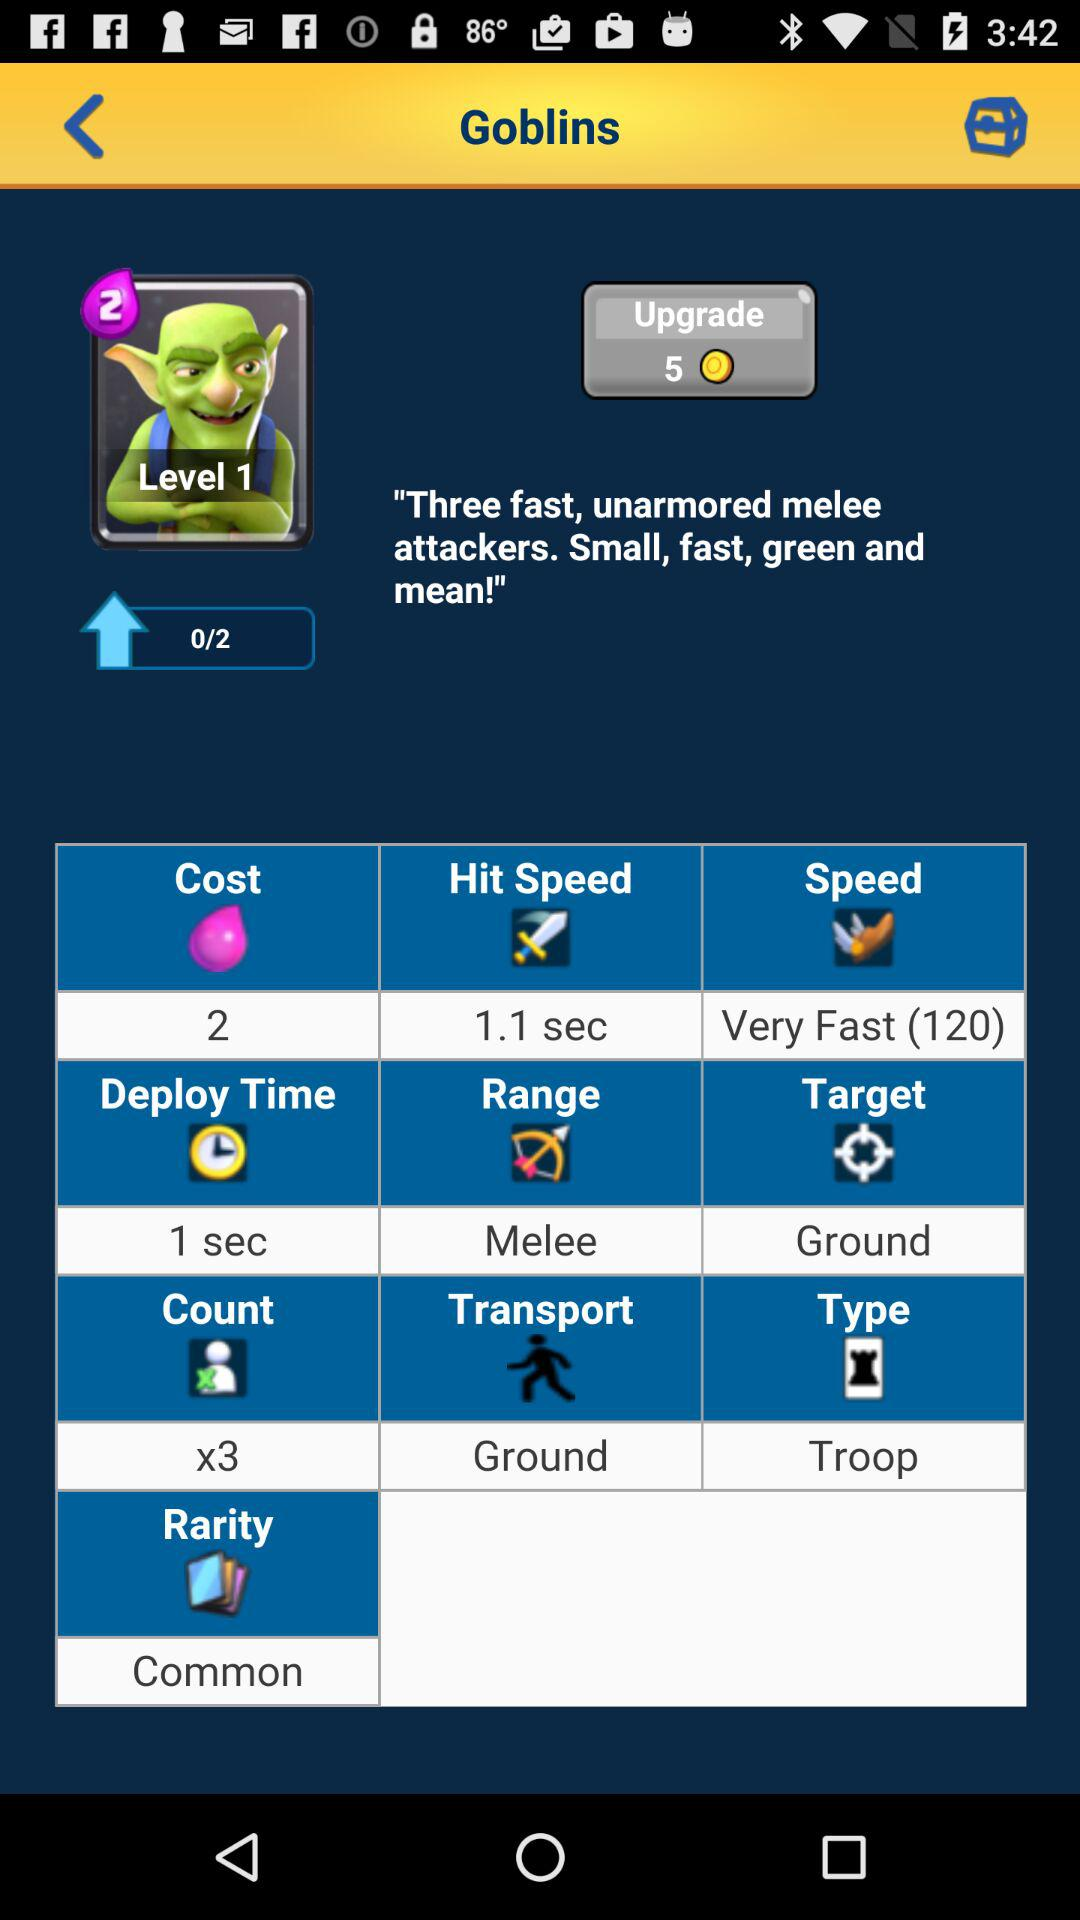Where does "Goblins" travel? "Goblins" travel on the ground. 